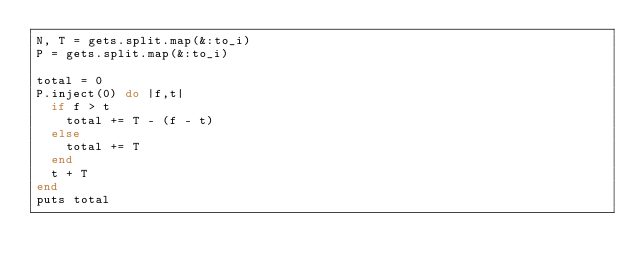<code> <loc_0><loc_0><loc_500><loc_500><_Ruby_>N, T = gets.split.map(&:to_i)
P = gets.split.map(&:to_i)

total = 0
P.inject(0) do |f,t|
  if f > t
    total += T - (f - t)
  else
    total += T
  end
  t + T
end
puts total
</code> 